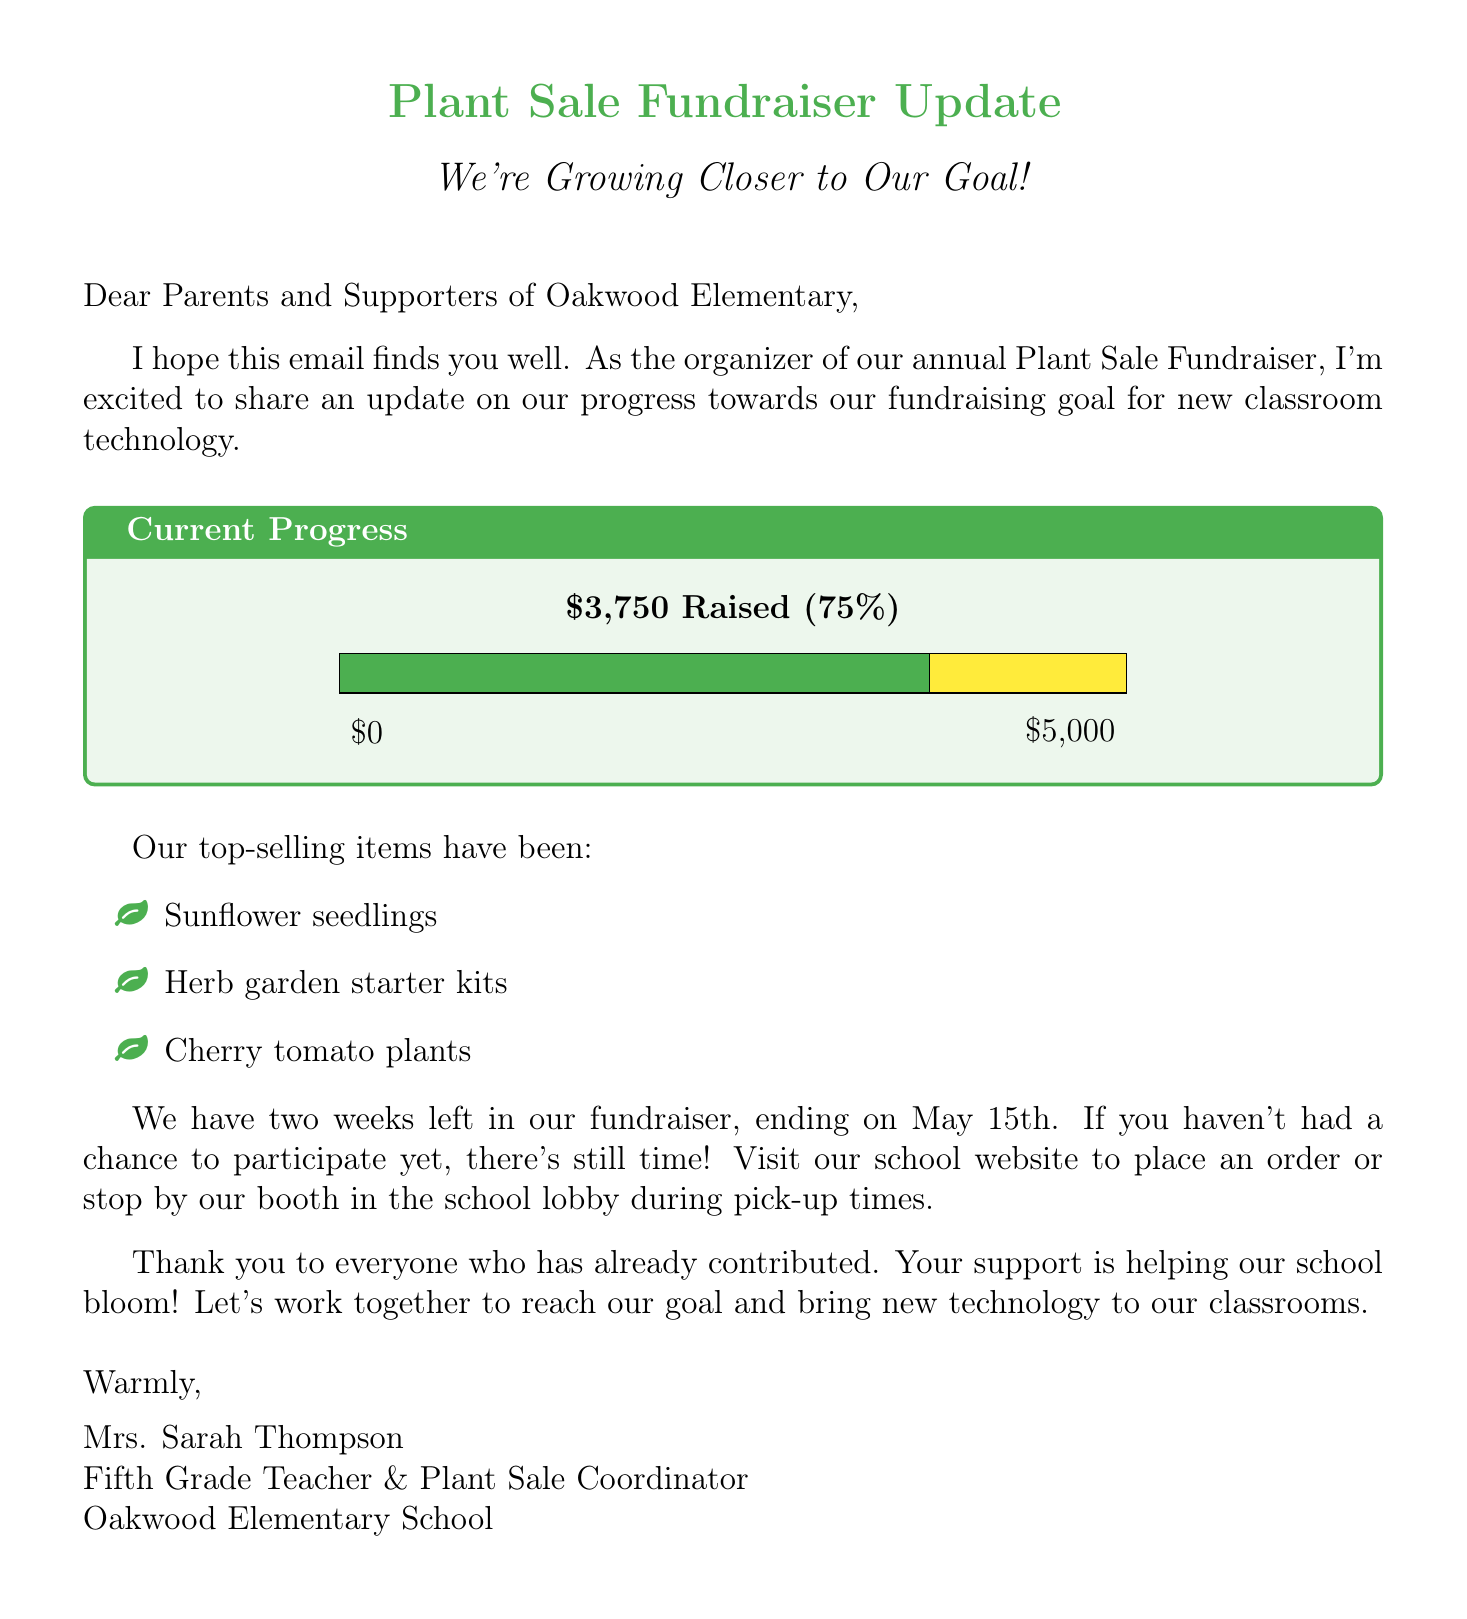What is the total amount raised so far? The total amount raised is stated in the document as $3,750.
Answer: $3,750 What percentage of the goal has been achieved? The document indicates that the percentage of the goal achieved is 75%.
Answer: 75% What is the fundraising goal? The fundraising goal is mentioned in the document as $5,000.
Answer: $5,000 How many weeks are left in the fundraiser? The document states that there are two weeks left until the fundraiser ends on May 15th.
Answer: Two weeks What are the top-selling items mentioned? The document lists the top-selling items as sunflower seedlings, herb garden starter kits, and cherry tomato plants.
Answer: Sunflower seedlings, herb garden starter kits, cherry tomato plants Who is the organizer of the plant sale fundraiser? The document identifies Mrs. Sarah Thompson as the organizer of the fundraiser.
Answer: Mrs. Sarah Thompson When does the fundraiser end? The end date of the fundraiser is specified as May 15th in the document.
Answer: May 15th What color represents the raised amount in the chart? The document states that the raised amount is represented by the green bar in the chart.
Answer: Green 